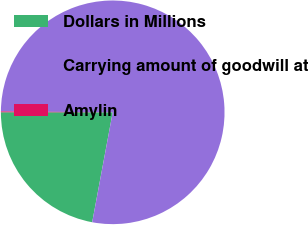<chart> <loc_0><loc_0><loc_500><loc_500><pie_chart><fcel>Dollars in Millions<fcel>Carrying amount of goodwill at<fcel>Amylin<nl><fcel>22.07%<fcel>77.81%<fcel>0.12%<nl></chart> 